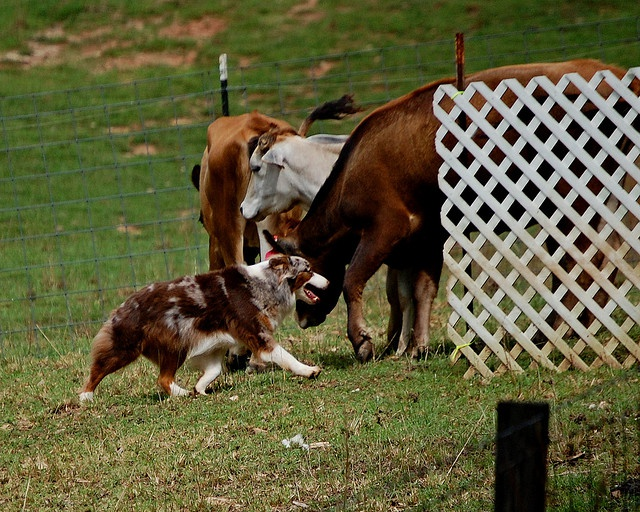Describe the objects in this image and their specific colors. I can see cow in darkgreen, black, maroon, and brown tones, dog in darkgreen, black, maroon, and gray tones, cow in darkgreen, black, maroon, olive, and gray tones, and cow in darkgreen, darkgray, black, gray, and maroon tones in this image. 